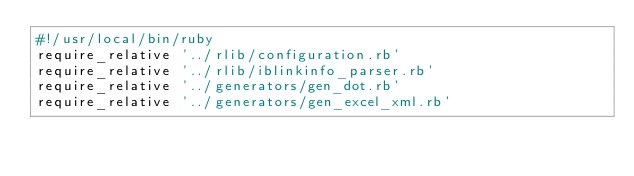Convert code to text. <code><loc_0><loc_0><loc_500><loc_500><_Ruby_>#!/usr/local/bin/ruby
require_relative '../rlib/configuration.rb'
require_relative '../rlib/iblinkinfo_parser.rb'
require_relative '../generators/gen_dot.rb'
require_relative '../generators/gen_excel_xml.rb'</code> 